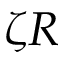Convert formula to latex. <formula><loc_0><loc_0><loc_500><loc_500>\zeta R</formula> 